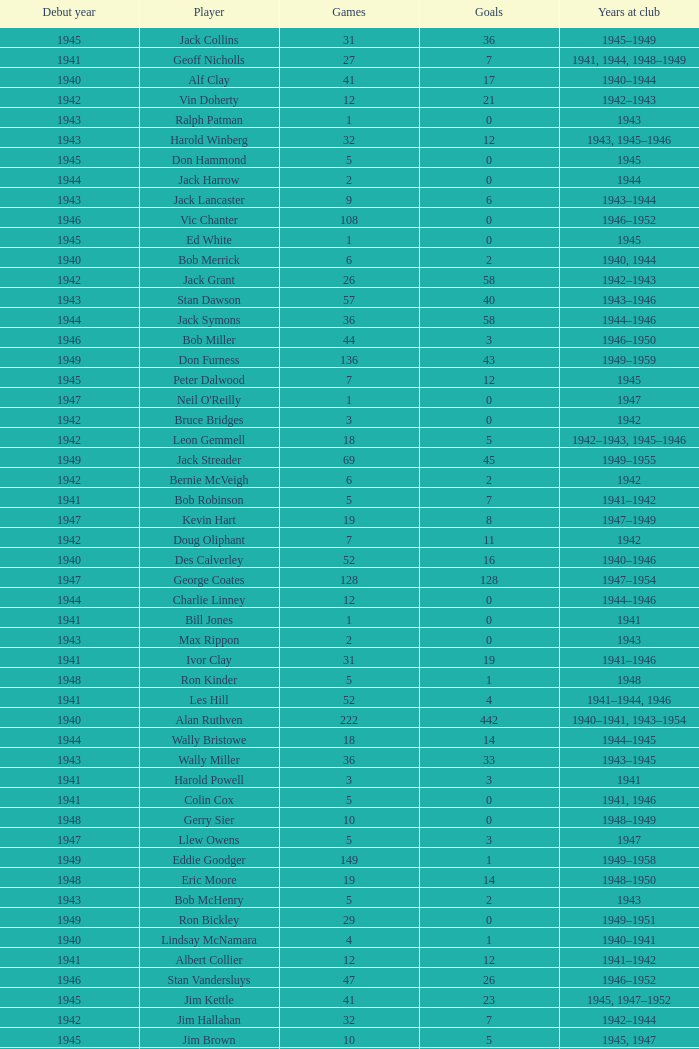Which player debuted before 1943, played for the club in 1942, played less than 12 games, and scored less than 11 goals? Bruce Bridges, George Watson, Reg Hammond, Angie Muller, Leo Hicks, Bernie McVeigh, Billy Hall. 